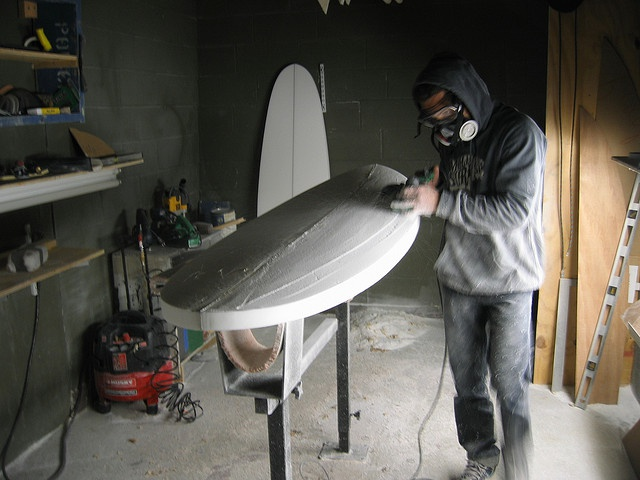Describe the objects in this image and their specific colors. I can see people in black, gray, darkgray, and lightgray tones, surfboard in black, lightgray, gray, and darkgray tones, and surfboard in black, darkgray, and gray tones in this image. 